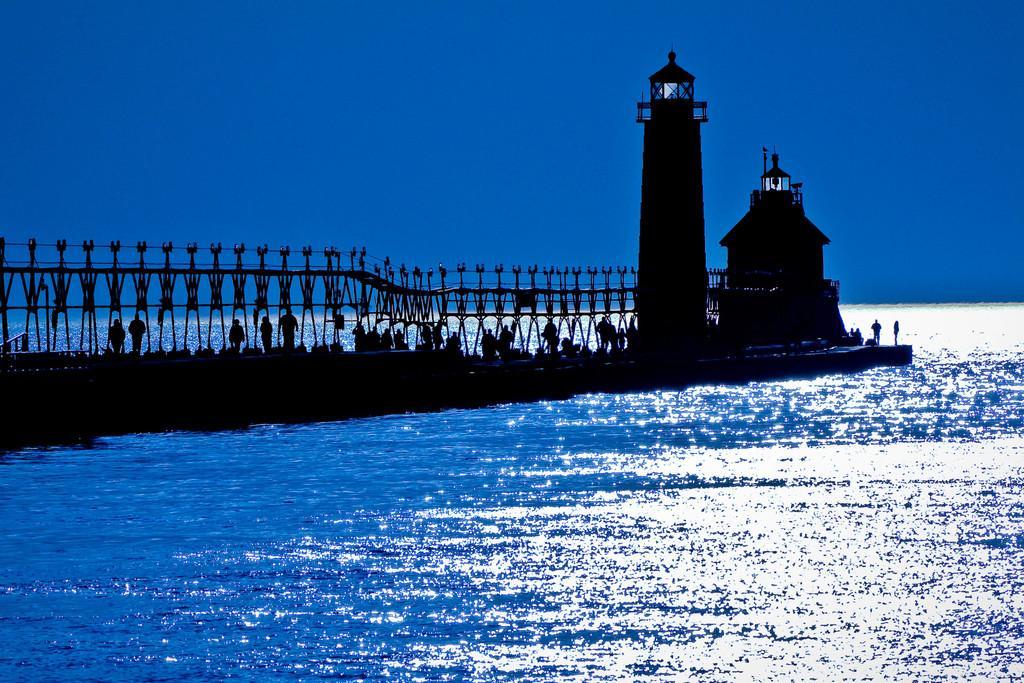Can you describe this image briefly? In this image I can see there is a bridge and there are a few people standing on it, there is a railing and there is a lighthouse and I can see there is a sea and the sky is clear. 